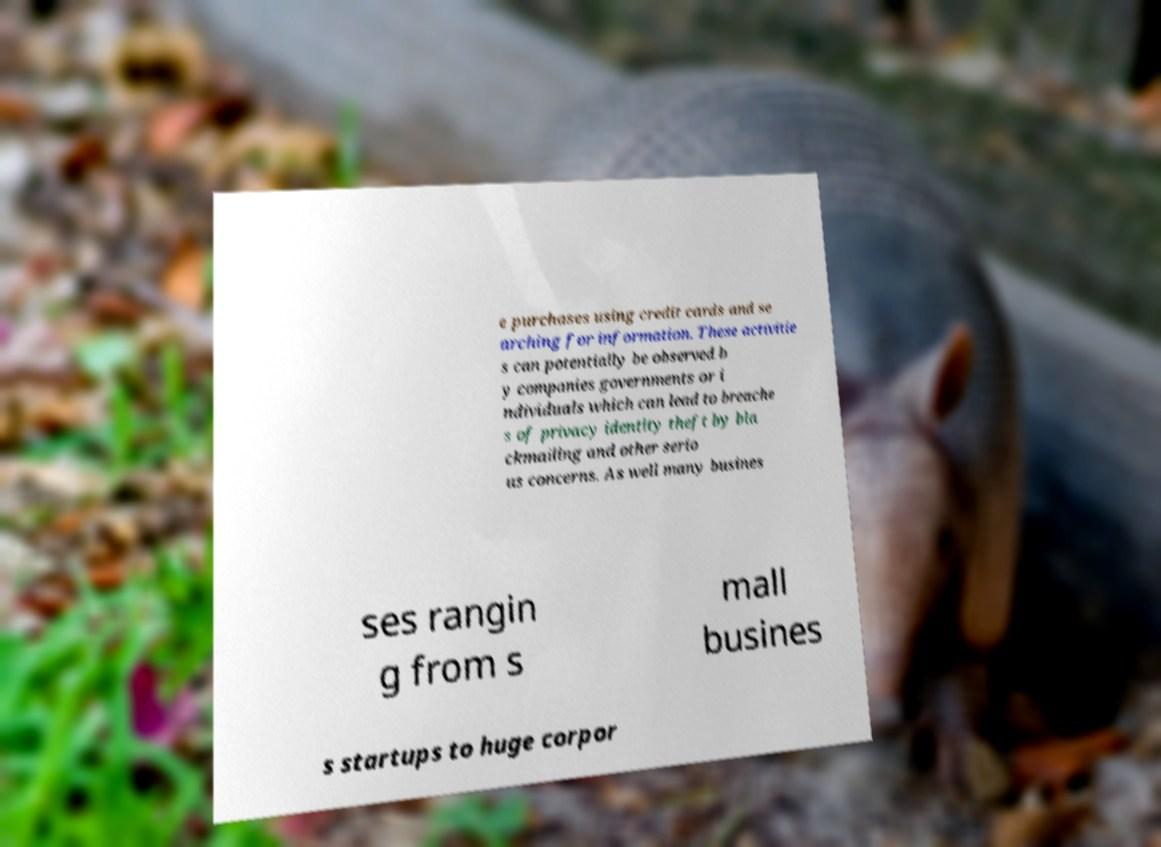There's text embedded in this image that I need extracted. Can you transcribe it verbatim? e purchases using credit cards and se arching for information. These activitie s can potentially be observed b y companies governments or i ndividuals which can lead to breache s of privacy identity theft by bla ckmailing and other serio us concerns. As well many busines ses rangin g from s mall busines s startups to huge corpor 